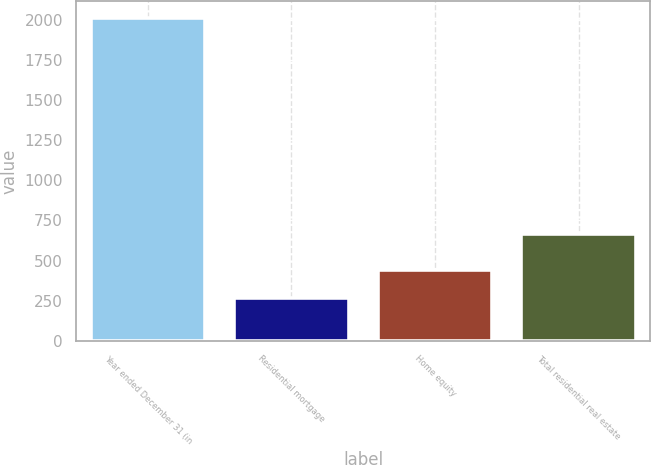Convert chart to OTSL. <chart><loc_0><loc_0><loc_500><loc_500><bar_chart><fcel>Year ended December 31 (in<fcel>Residential mortgage<fcel>Home equity<fcel>Total residential real estate<nl><fcel>2015<fcel>267<fcel>441.8<fcel>668<nl></chart> 